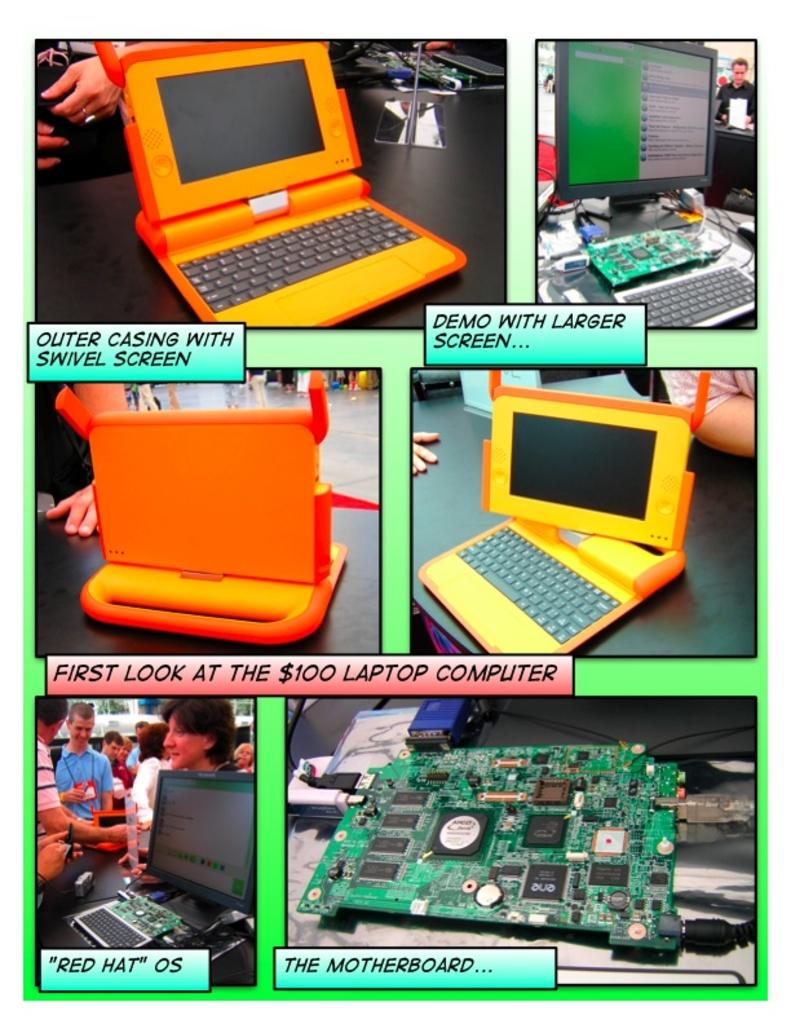<image>
Write a terse but informative summary of the picture. Pictures of a laptop being build says first look at the $100 laptop. 